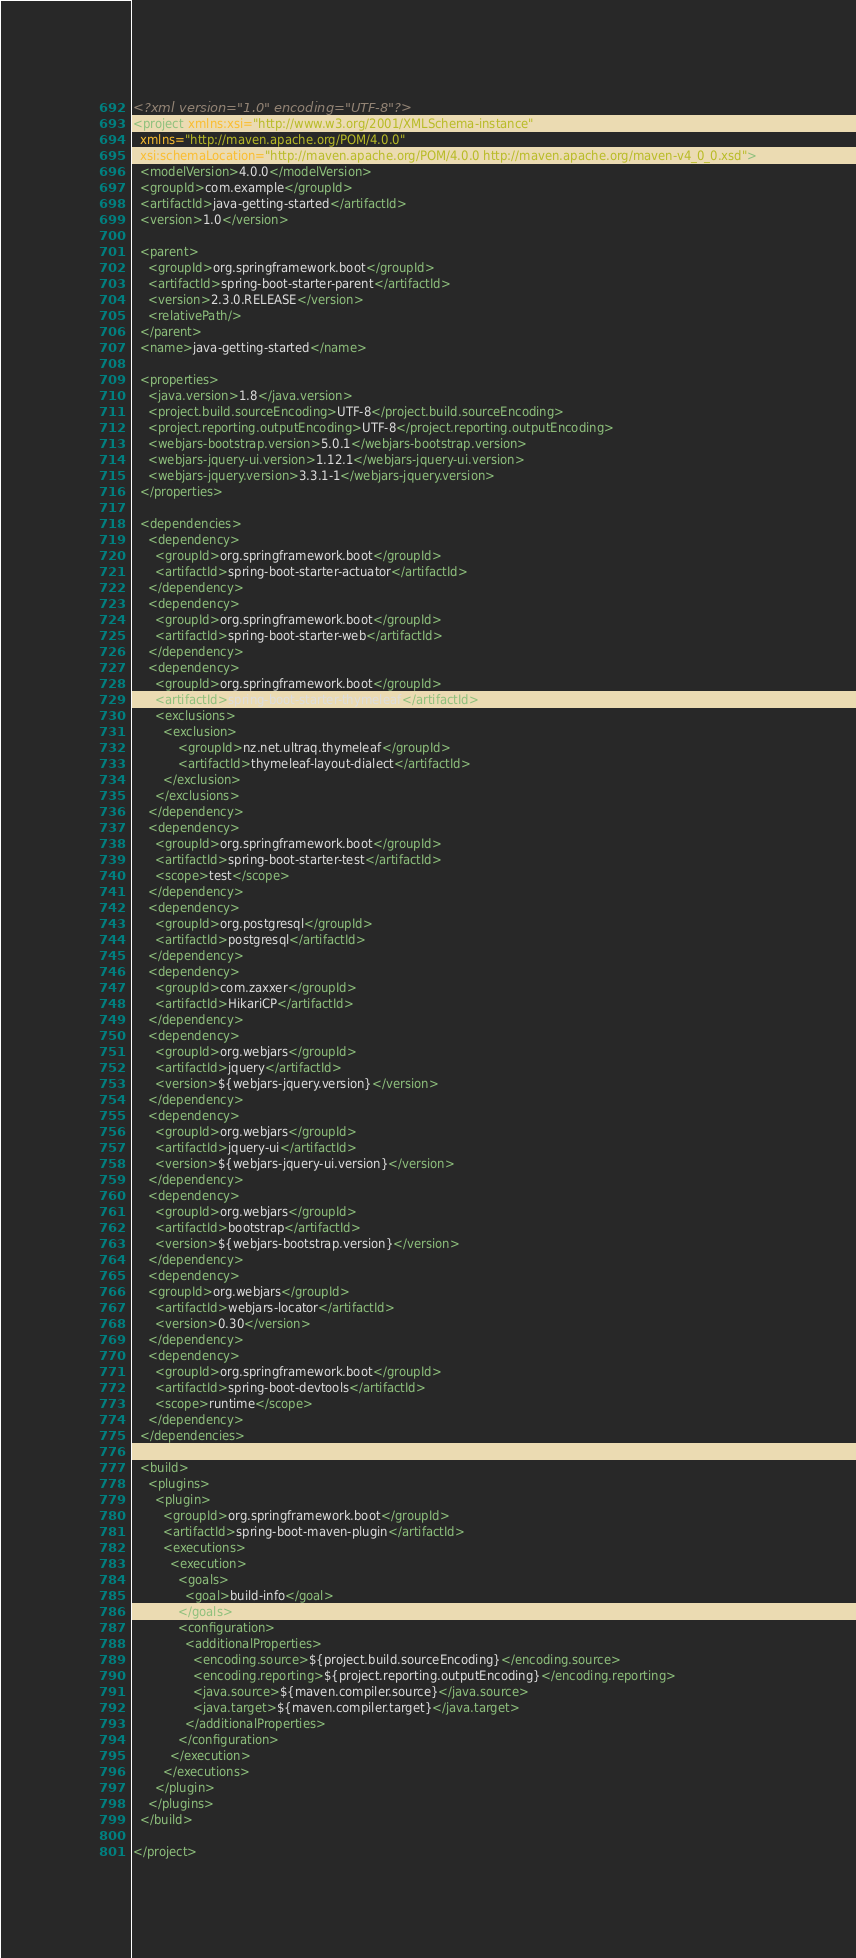<code> <loc_0><loc_0><loc_500><loc_500><_XML_><?xml version="1.0" encoding="UTF-8"?>
<project xmlns:xsi="http://www.w3.org/2001/XMLSchema-instance"
  xmlns="http://maven.apache.org/POM/4.0.0"
  xsi:schemaLocation="http://maven.apache.org/POM/4.0.0 http://maven.apache.org/maven-v4_0_0.xsd">
  <modelVersion>4.0.0</modelVersion>
  <groupId>com.example</groupId>
  <artifactId>java-getting-started</artifactId>
  <version>1.0</version>

  <parent>
    <groupId>org.springframework.boot</groupId>
    <artifactId>spring-boot-starter-parent</artifactId>
    <version>2.3.0.RELEASE</version>
    <relativePath/>
  </parent>
  <name>java-getting-started</name>

  <properties>
    <java.version>1.8</java.version>
    <project.build.sourceEncoding>UTF-8</project.build.sourceEncoding>
    <project.reporting.outputEncoding>UTF-8</project.reporting.outputEncoding>
    <webjars-bootstrap.version>5.0.1</webjars-bootstrap.version>
    <webjars-jquery-ui.version>1.12.1</webjars-jquery-ui.version>
    <webjars-jquery.version>3.3.1-1</webjars-jquery.version>
  </properties>

  <dependencies>
    <dependency>
      <groupId>org.springframework.boot</groupId>
      <artifactId>spring-boot-starter-actuator</artifactId>
    </dependency>
    <dependency>
      <groupId>org.springframework.boot</groupId>
      <artifactId>spring-boot-starter-web</artifactId>
    </dependency>
    <dependency>
      <groupId>org.springframework.boot</groupId>
      <artifactId>spring-boot-starter-thymeleaf</artifactId>
      <exclusions>
      	<exclusion>
      		<groupId>nz.net.ultraq.thymeleaf</groupId>
      		<artifactId>thymeleaf-layout-dialect</artifactId>
      	</exclusion>
      </exclusions>
    </dependency>
    <dependency>
      <groupId>org.springframework.boot</groupId>
      <artifactId>spring-boot-starter-test</artifactId>
      <scope>test</scope>
    </dependency>
    <dependency>
      <groupId>org.postgresql</groupId>
      <artifactId>postgresql</artifactId>
    </dependency>
    <dependency>
      <groupId>com.zaxxer</groupId>
      <artifactId>HikariCP</artifactId>
    </dependency>
    <dependency>
      <groupId>org.webjars</groupId>
      <artifactId>jquery</artifactId>
      <version>${webjars-jquery.version}</version>
    </dependency>
    <dependency>
      <groupId>org.webjars</groupId>
      <artifactId>jquery-ui</artifactId>
      <version>${webjars-jquery-ui.version}</version>
    </dependency>
    <dependency>
      <groupId>org.webjars</groupId>
      <artifactId>bootstrap</artifactId>
      <version>${webjars-bootstrap.version}</version>
    </dependency>
    <dependency>
    <groupId>org.webjars</groupId>
      <artifactId>webjars-locator</artifactId>
      <version>0.30</version>
    </dependency>
    <dependency>
      <groupId>org.springframework.boot</groupId>
      <artifactId>spring-boot-devtools</artifactId>
      <scope>runtime</scope>
    </dependency>
  </dependencies>

  <build>
    <plugins>
      <plugin>
        <groupId>org.springframework.boot</groupId>
        <artifactId>spring-boot-maven-plugin</artifactId>
        <executions>
          <execution>
            <goals>
              <goal>build-info</goal>
            </goals>
            <configuration>
              <additionalProperties>
                <encoding.source>${project.build.sourceEncoding}</encoding.source>
                <encoding.reporting>${project.reporting.outputEncoding}</encoding.reporting>
                <java.source>${maven.compiler.source}</java.source>
                <java.target>${maven.compiler.target}</java.target>
              </additionalProperties>
            </configuration>
          </execution>
        </executions>
      </plugin>
    </plugins>
  </build>

</project>
</code> 